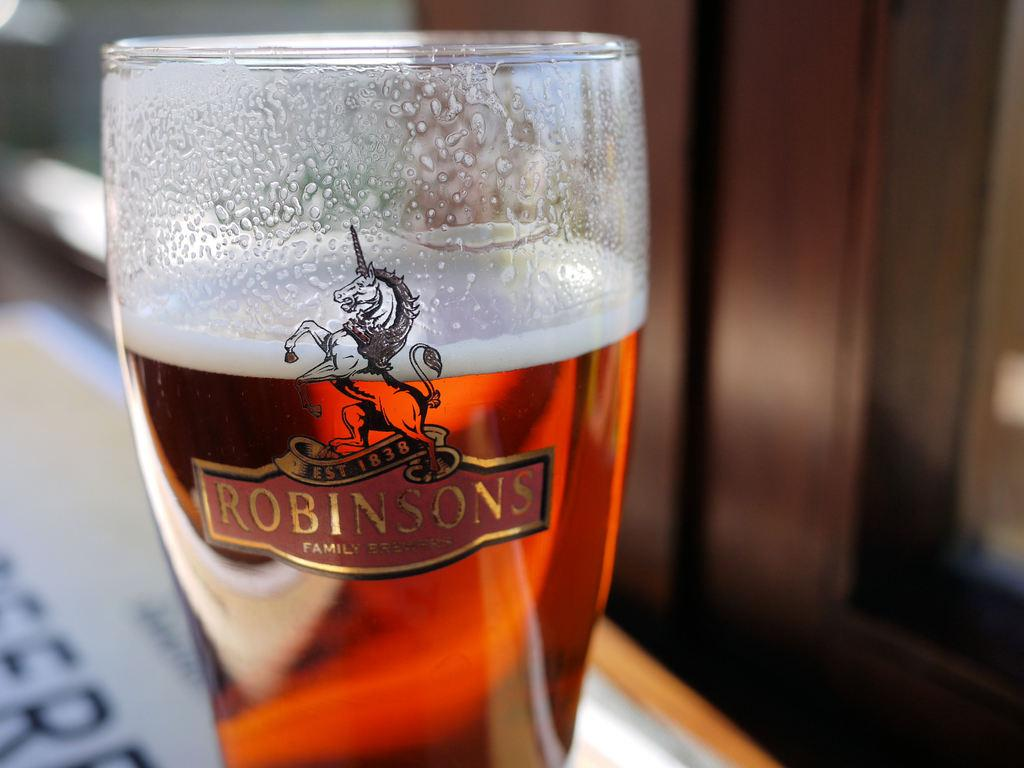<image>
Write a terse but informative summary of the picture. A glass, which bears the Robinsons logo, is full of liquid. 